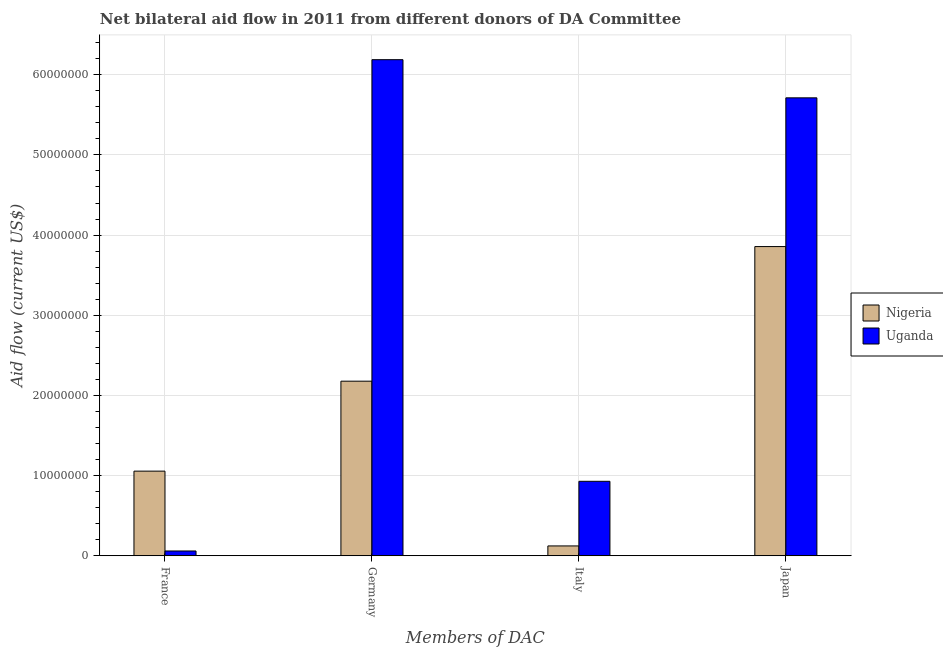Are the number of bars per tick equal to the number of legend labels?
Offer a terse response. Yes. Are the number of bars on each tick of the X-axis equal?
Offer a very short reply. Yes. How many bars are there on the 3rd tick from the right?
Offer a terse response. 2. What is the label of the 2nd group of bars from the left?
Provide a short and direct response. Germany. What is the amount of aid given by germany in Nigeria?
Your response must be concise. 2.18e+07. Across all countries, what is the maximum amount of aid given by italy?
Your answer should be compact. 9.29e+06. Across all countries, what is the minimum amount of aid given by france?
Offer a terse response. 6.00e+05. In which country was the amount of aid given by germany maximum?
Your answer should be compact. Uganda. In which country was the amount of aid given by italy minimum?
Keep it short and to the point. Nigeria. What is the total amount of aid given by france in the graph?
Keep it short and to the point. 1.12e+07. What is the difference between the amount of aid given by france in Nigeria and that in Uganda?
Your response must be concise. 9.96e+06. What is the difference between the amount of aid given by france in Uganda and the amount of aid given by germany in Nigeria?
Offer a terse response. -2.12e+07. What is the average amount of aid given by france per country?
Your response must be concise. 5.58e+06. What is the difference between the amount of aid given by japan and amount of aid given by germany in Nigeria?
Your answer should be very brief. 1.68e+07. What is the ratio of the amount of aid given by italy in Nigeria to that in Uganda?
Your response must be concise. 0.13. What is the difference between the highest and the second highest amount of aid given by germany?
Make the answer very short. 4.01e+07. What is the difference between the highest and the lowest amount of aid given by japan?
Make the answer very short. 1.86e+07. In how many countries, is the amount of aid given by france greater than the average amount of aid given by france taken over all countries?
Keep it short and to the point. 1. Is the sum of the amount of aid given by italy in Uganda and Nigeria greater than the maximum amount of aid given by japan across all countries?
Offer a terse response. No. Is it the case that in every country, the sum of the amount of aid given by france and amount of aid given by germany is greater than the sum of amount of aid given by japan and amount of aid given by italy?
Your answer should be compact. Yes. What does the 1st bar from the left in Italy represents?
Keep it short and to the point. Nigeria. What does the 1st bar from the right in Italy represents?
Your answer should be very brief. Uganda. Is it the case that in every country, the sum of the amount of aid given by france and amount of aid given by germany is greater than the amount of aid given by italy?
Provide a short and direct response. Yes. How many bars are there?
Offer a terse response. 8. Are all the bars in the graph horizontal?
Your response must be concise. No. How many countries are there in the graph?
Offer a very short reply. 2. Are the values on the major ticks of Y-axis written in scientific E-notation?
Your answer should be compact. No. Where does the legend appear in the graph?
Make the answer very short. Center right. What is the title of the graph?
Ensure brevity in your answer.  Net bilateral aid flow in 2011 from different donors of DA Committee. What is the label or title of the X-axis?
Your answer should be very brief. Members of DAC. What is the label or title of the Y-axis?
Your response must be concise. Aid flow (current US$). What is the Aid flow (current US$) in Nigeria in France?
Your answer should be compact. 1.06e+07. What is the Aid flow (current US$) in Nigeria in Germany?
Your answer should be very brief. 2.18e+07. What is the Aid flow (current US$) in Uganda in Germany?
Your response must be concise. 6.19e+07. What is the Aid flow (current US$) of Nigeria in Italy?
Give a very brief answer. 1.23e+06. What is the Aid flow (current US$) in Uganda in Italy?
Give a very brief answer. 9.29e+06. What is the Aid flow (current US$) of Nigeria in Japan?
Provide a succinct answer. 3.86e+07. What is the Aid flow (current US$) of Uganda in Japan?
Keep it short and to the point. 5.71e+07. Across all Members of DAC, what is the maximum Aid flow (current US$) of Nigeria?
Your response must be concise. 3.86e+07. Across all Members of DAC, what is the maximum Aid flow (current US$) in Uganda?
Offer a very short reply. 6.19e+07. Across all Members of DAC, what is the minimum Aid flow (current US$) of Nigeria?
Provide a succinct answer. 1.23e+06. What is the total Aid flow (current US$) in Nigeria in the graph?
Your response must be concise. 7.21e+07. What is the total Aid flow (current US$) of Uganda in the graph?
Your response must be concise. 1.29e+08. What is the difference between the Aid flow (current US$) of Nigeria in France and that in Germany?
Your answer should be very brief. -1.12e+07. What is the difference between the Aid flow (current US$) of Uganda in France and that in Germany?
Make the answer very short. -6.13e+07. What is the difference between the Aid flow (current US$) in Nigeria in France and that in Italy?
Your response must be concise. 9.33e+06. What is the difference between the Aid flow (current US$) in Uganda in France and that in Italy?
Ensure brevity in your answer.  -8.69e+06. What is the difference between the Aid flow (current US$) in Nigeria in France and that in Japan?
Make the answer very short. -2.80e+07. What is the difference between the Aid flow (current US$) of Uganda in France and that in Japan?
Ensure brevity in your answer.  -5.65e+07. What is the difference between the Aid flow (current US$) in Nigeria in Germany and that in Italy?
Keep it short and to the point. 2.06e+07. What is the difference between the Aid flow (current US$) in Uganda in Germany and that in Italy?
Keep it short and to the point. 5.26e+07. What is the difference between the Aid flow (current US$) in Nigeria in Germany and that in Japan?
Your answer should be compact. -1.68e+07. What is the difference between the Aid flow (current US$) in Uganda in Germany and that in Japan?
Provide a succinct answer. 4.76e+06. What is the difference between the Aid flow (current US$) of Nigeria in Italy and that in Japan?
Provide a short and direct response. -3.73e+07. What is the difference between the Aid flow (current US$) of Uganda in Italy and that in Japan?
Keep it short and to the point. -4.78e+07. What is the difference between the Aid flow (current US$) of Nigeria in France and the Aid flow (current US$) of Uganda in Germany?
Give a very brief answer. -5.13e+07. What is the difference between the Aid flow (current US$) of Nigeria in France and the Aid flow (current US$) of Uganda in Italy?
Your answer should be very brief. 1.27e+06. What is the difference between the Aid flow (current US$) of Nigeria in France and the Aid flow (current US$) of Uganda in Japan?
Make the answer very short. -4.66e+07. What is the difference between the Aid flow (current US$) in Nigeria in Germany and the Aid flow (current US$) in Uganda in Italy?
Your answer should be very brief. 1.25e+07. What is the difference between the Aid flow (current US$) in Nigeria in Germany and the Aid flow (current US$) in Uganda in Japan?
Your answer should be very brief. -3.53e+07. What is the difference between the Aid flow (current US$) of Nigeria in Italy and the Aid flow (current US$) of Uganda in Japan?
Your answer should be compact. -5.59e+07. What is the average Aid flow (current US$) in Nigeria per Members of DAC?
Offer a very short reply. 1.80e+07. What is the average Aid flow (current US$) in Uganda per Members of DAC?
Keep it short and to the point. 3.22e+07. What is the difference between the Aid flow (current US$) in Nigeria and Aid flow (current US$) in Uganda in France?
Your response must be concise. 9.96e+06. What is the difference between the Aid flow (current US$) of Nigeria and Aid flow (current US$) of Uganda in Germany?
Provide a short and direct response. -4.01e+07. What is the difference between the Aid flow (current US$) in Nigeria and Aid flow (current US$) in Uganda in Italy?
Your answer should be very brief. -8.06e+06. What is the difference between the Aid flow (current US$) of Nigeria and Aid flow (current US$) of Uganda in Japan?
Give a very brief answer. -1.86e+07. What is the ratio of the Aid flow (current US$) of Nigeria in France to that in Germany?
Offer a very short reply. 0.48. What is the ratio of the Aid flow (current US$) of Uganda in France to that in Germany?
Offer a terse response. 0.01. What is the ratio of the Aid flow (current US$) in Nigeria in France to that in Italy?
Your answer should be very brief. 8.59. What is the ratio of the Aid flow (current US$) of Uganda in France to that in Italy?
Keep it short and to the point. 0.06. What is the ratio of the Aid flow (current US$) of Nigeria in France to that in Japan?
Make the answer very short. 0.27. What is the ratio of the Aid flow (current US$) of Uganda in France to that in Japan?
Your answer should be compact. 0.01. What is the ratio of the Aid flow (current US$) in Nigeria in Germany to that in Italy?
Ensure brevity in your answer.  17.71. What is the ratio of the Aid flow (current US$) of Uganda in Germany to that in Italy?
Offer a terse response. 6.66. What is the ratio of the Aid flow (current US$) of Nigeria in Germany to that in Japan?
Your response must be concise. 0.56. What is the ratio of the Aid flow (current US$) in Nigeria in Italy to that in Japan?
Provide a short and direct response. 0.03. What is the ratio of the Aid flow (current US$) of Uganda in Italy to that in Japan?
Offer a terse response. 0.16. What is the difference between the highest and the second highest Aid flow (current US$) in Nigeria?
Ensure brevity in your answer.  1.68e+07. What is the difference between the highest and the second highest Aid flow (current US$) of Uganda?
Your answer should be compact. 4.76e+06. What is the difference between the highest and the lowest Aid flow (current US$) in Nigeria?
Make the answer very short. 3.73e+07. What is the difference between the highest and the lowest Aid flow (current US$) of Uganda?
Give a very brief answer. 6.13e+07. 